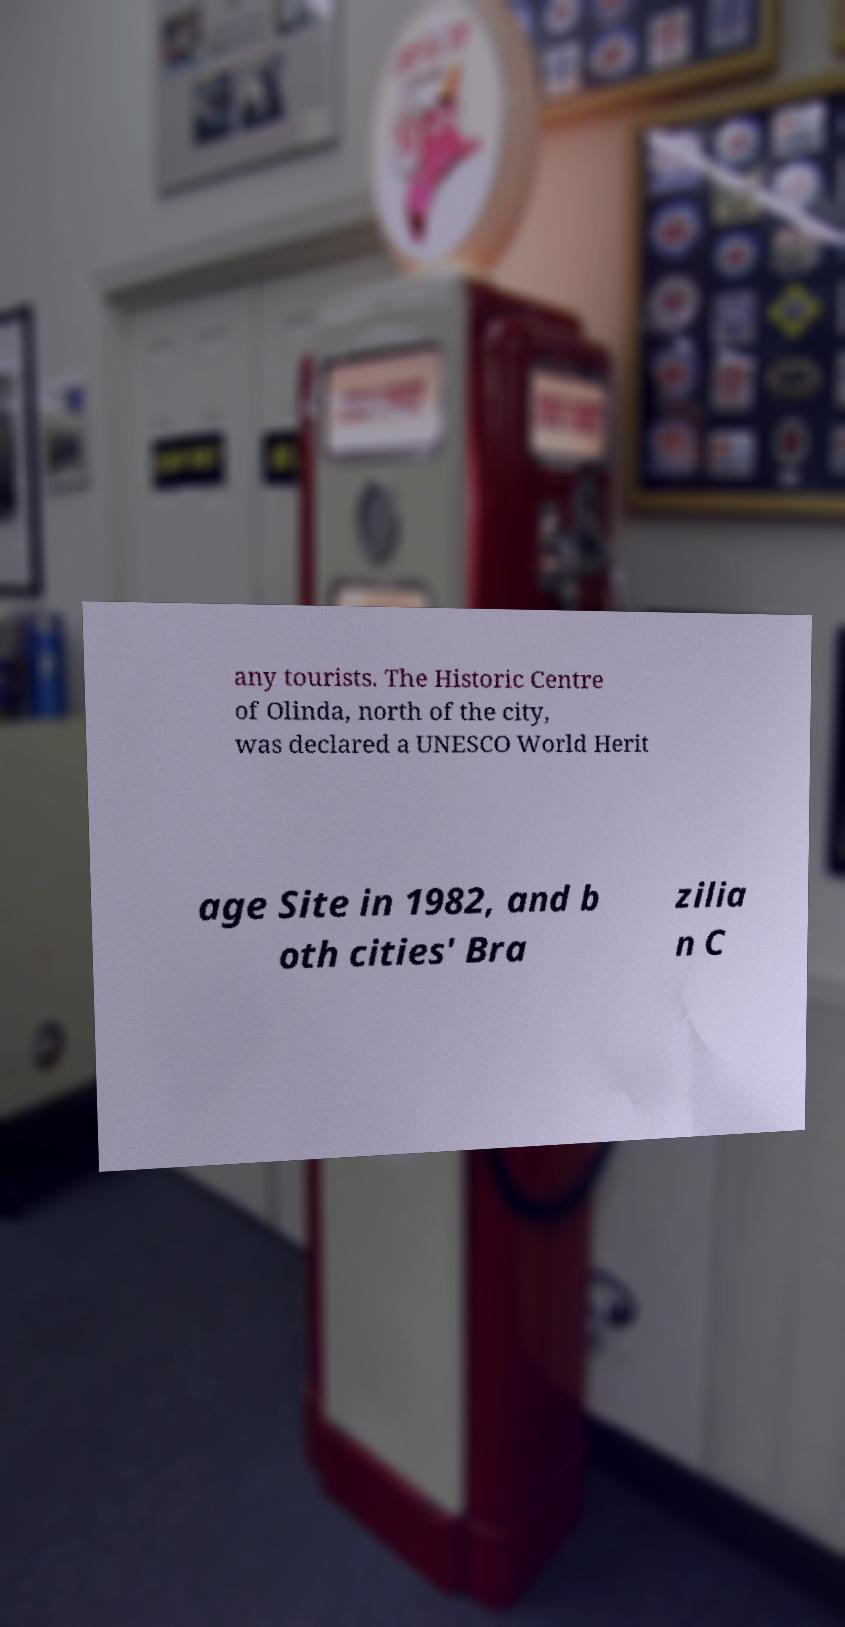Could you assist in decoding the text presented in this image and type it out clearly? any tourists. The Historic Centre of Olinda, north of the city, was declared a UNESCO World Herit age Site in 1982, and b oth cities' Bra zilia n C 